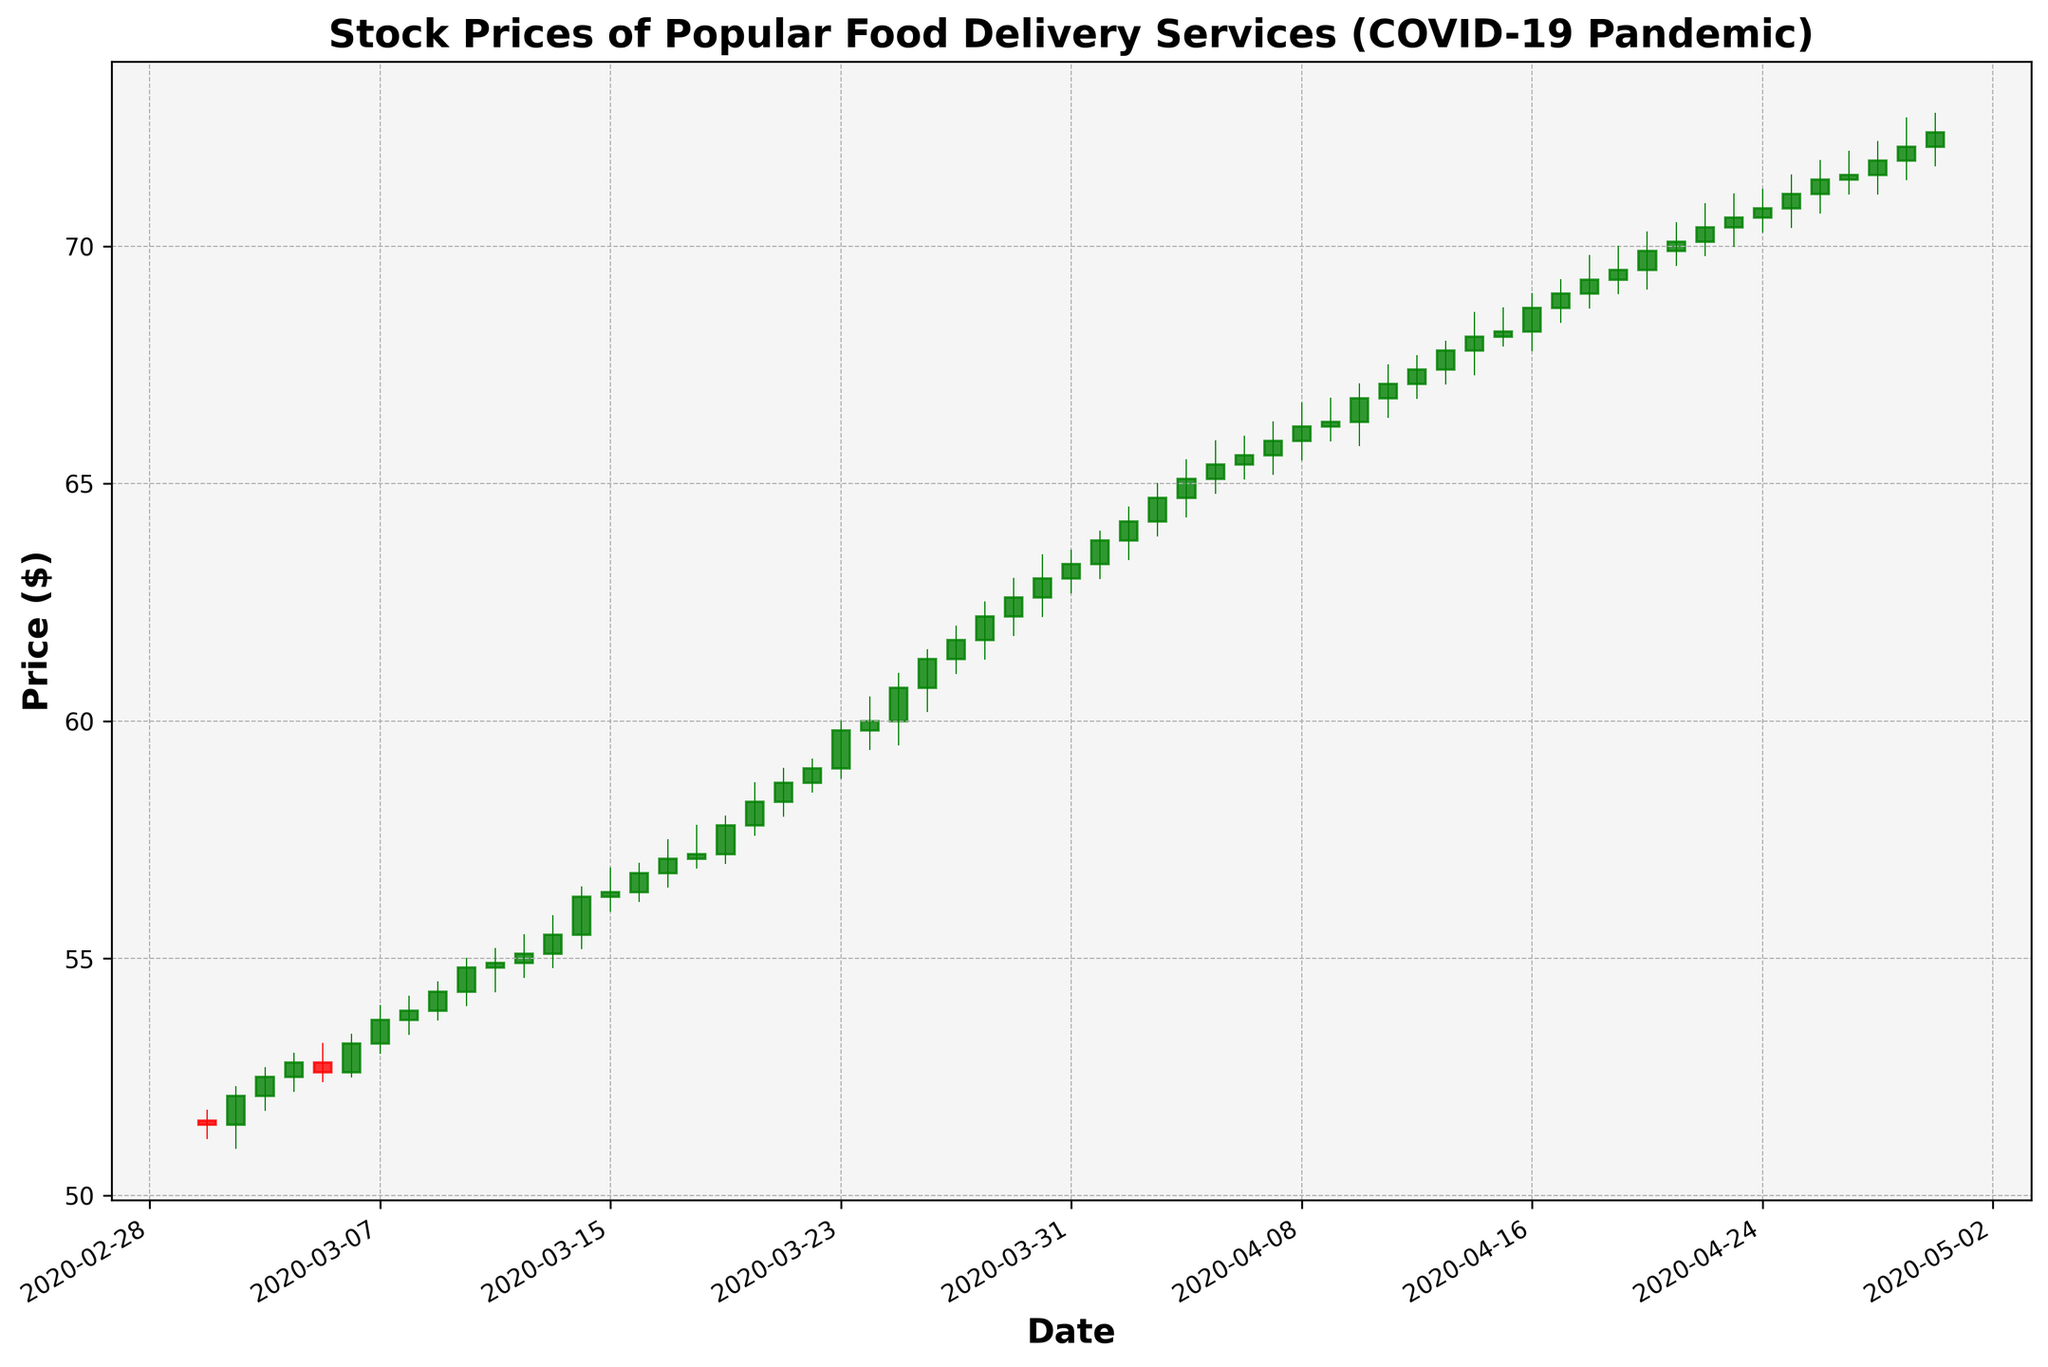What is the initial stock price on March 1st, 2020? On March 1st, 2020, the opening price of the stock can be read directly from the figure. It is the first green or red candle's opening price.
Answer: 51.58 How does the closing price on March 10th compare to the opening price on the same day? Look at the candlestick corresponding to March 10th. The opening price is the bottom of the body, and the closing price is the top of the body, indicating if there was an increase.
Answer: The close price is higher than the open price What's the overall trend in stock prices from March 1st to March 14th? Starting from March 1st to March 14th, analyze the general direction of the candlesticks. Are they generally moving higher or lower?
Answer: The overall trend is upward Between March 20th and April 1st, which day saw the highest peak price? Review the highs of each candlestick from March 20th to April 1st and identify the one with the highest value.
Answer: March 31st Calculate the average closing price for the first 5 days in April. Sum up the closing prices from April 1st to April 5th and divide by 5: (63.30 + 64.20 + 64.70 + 65.10 + 65.40) / 5
Answer: 64.14 Which day had the highest trading volume? Identify the candlestick that corresponds to the highest volume by examining the data in the figure.
Answer: March 3rd By how much did the closing price change from March 1st to March 31st? Subtract the closing price on March 1st from the closing price on March 31st: 63.30 - 51.50
Answer: 11.80 How many days in March had increasing closing prices compared to the day before? Count the number of green candlesticks from March 1st to March 31st as they indicate a day where the closing price was higher than the previous day's close.
Answer: 19 days How did the stock price on April 14th compare to April 13th? Compare the closing price on April 13th and April 14th by looking at the top of the body of the candlestick for these dates.
Answer: April 14th close was slightly higher What's the average trading volume in April? Sum up the trading volumes for all the days in April and divide by the number of days in April: (1200000 + 1300000 + 1400000 + 1300000 + 1200000 + 1100000 + 1000000 + 1100000 + 1200000 + 1300000 + 1400000 + 1300000 + 1200000 + 1100000 + 1000000 + 1100000 + 1200000 + 1300000 + 1400000 + 1300000 + 1200000 + 1100000 + 1000000 + 1100000 + 1200000 + 1300000 + 1400000 + 1300000 + 1200000 + 1100000) / 30
Answer: 1,193,333 